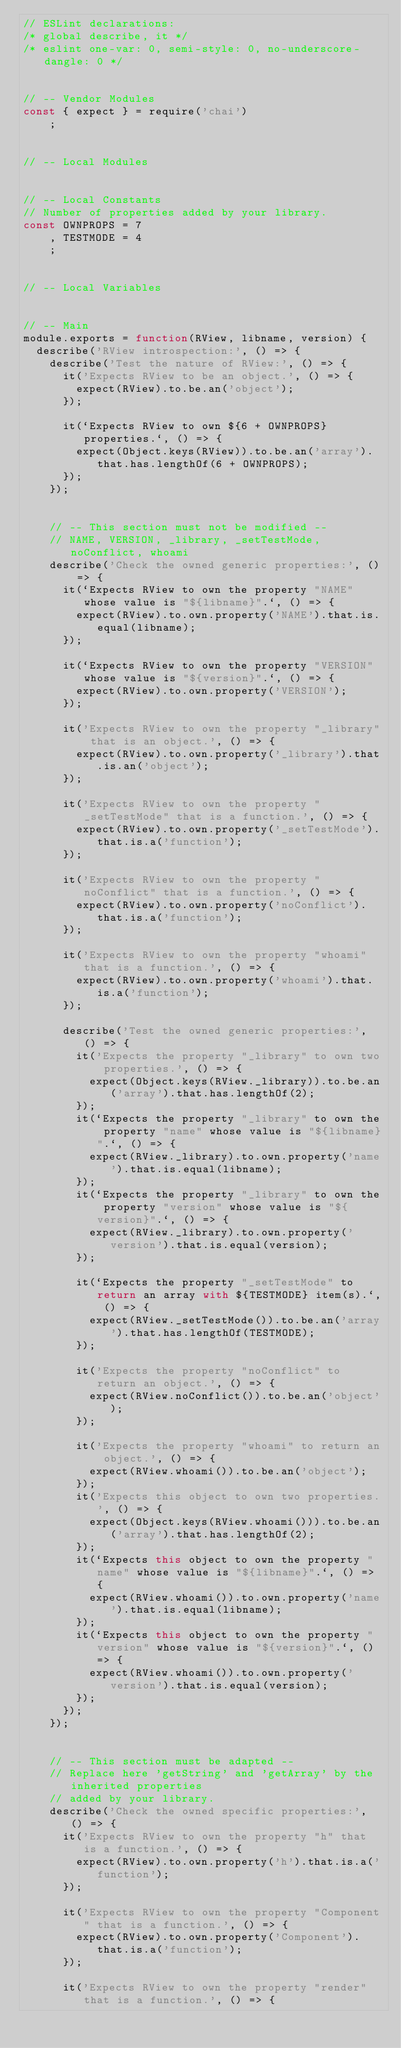Convert code to text. <code><loc_0><loc_0><loc_500><loc_500><_JavaScript_>// ESLint declarations:
/* global describe, it */
/* eslint one-var: 0, semi-style: 0, no-underscore-dangle: 0 */


// -- Vendor Modules
const { expect } = require('chai')
    ;


// -- Local Modules


// -- Local Constants
// Number of properties added by your library.
const OWNPROPS = 7
    , TESTMODE = 4
    ;


// -- Local Variables


// -- Main
module.exports = function(RView, libname, version) {
  describe('RView introspection:', () => {
    describe('Test the nature of RView:', () => {
      it('Expects RView to be an object.', () => {
        expect(RView).to.be.an('object');
      });

      it(`Expects RView to own ${6 + OWNPROPS} properties.`, () => {
        expect(Object.keys(RView)).to.be.an('array').that.has.lengthOf(6 + OWNPROPS);
      });
    });


    // -- This section must not be modified --
    // NAME, VERSION, _library, _setTestMode, noConflict, whoami
    describe('Check the owned generic properties:', () => {
      it(`Expects RView to own the property "NAME" whose value is "${libname}".`, () => {
        expect(RView).to.own.property('NAME').that.is.equal(libname);
      });

      it(`Expects RView to own the property "VERSION" whose value is "${version}".`, () => {
        expect(RView).to.own.property('VERSION');
      });

      it('Expects RView to own the property "_library" that is an object.', () => {
        expect(RView).to.own.property('_library').that.is.an('object');
      });

      it('Expects RView to own the property "_setTestMode" that is a function.', () => {
        expect(RView).to.own.property('_setTestMode').that.is.a('function');
      });

      it('Expects RView to own the property "noConflict" that is a function.', () => {
        expect(RView).to.own.property('noConflict').that.is.a('function');
      });

      it('Expects RView to own the property "whoami" that is a function.', () => {
        expect(RView).to.own.property('whoami').that.is.a('function');
      });

      describe('Test the owned generic properties:', () => {
        it('Expects the property "_library" to own two properties.', () => {
          expect(Object.keys(RView._library)).to.be.an('array').that.has.lengthOf(2);
        });
        it(`Expects the property "_library" to own the property "name" whose value is "${libname}".`, () => {
          expect(RView._library).to.own.property('name').that.is.equal(libname);
        });
        it(`Expects the property "_library" to own the property "version" whose value is "${version}".`, () => {
          expect(RView._library).to.own.property('version').that.is.equal(version);
        });

        it(`Expects the property "_setTestMode" to return an array with ${TESTMODE} item(s).`, () => {
          expect(RView._setTestMode()).to.be.an('array').that.has.lengthOf(TESTMODE);
        });

        it('Expects the property "noConflict" to return an object.', () => {
          expect(RView.noConflict()).to.be.an('object');
        });

        it('Expects the property "whoami" to return an object.', () => {
          expect(RView.whoami()).to.be.an('object');
        });
        it('Expects this object to own two properties.', () => {
          expect(Object.keys(RView.whoami())).to.be.an('array').that.has.lengthOf(2);
        });
        it(`Expects this object to own the property "name" whose value is "${libname}".`, () => {
          expect(RView.whoami()).to.own.property('name').that.is.equal(libname);
        });
        it(`Expects this object to own the property "version" whose value is "${version}".`, () => {
          expect(RView.whoami()).to.own.property('version').that.is.equal(version);
        });
      });
    });


    // -- This section must be adapted --
    // Replace here 'getString' and 'getArray' by the inherited properties
    // added by your library.
    describe('Check the owned specific properties:', () => {
      it('Expects RView to own the property "h" that is a function.', () => {
        expect(RView).to.own.property('h').that.is.a('function');
      });

      it('Expects RView to own the property "Component" that is a function.', () => {
        expect(RView).to.own.property('Component').that.is.a('function');
      });

      it('Expects RView to own the property "render" that is a function.', () => {</code> 